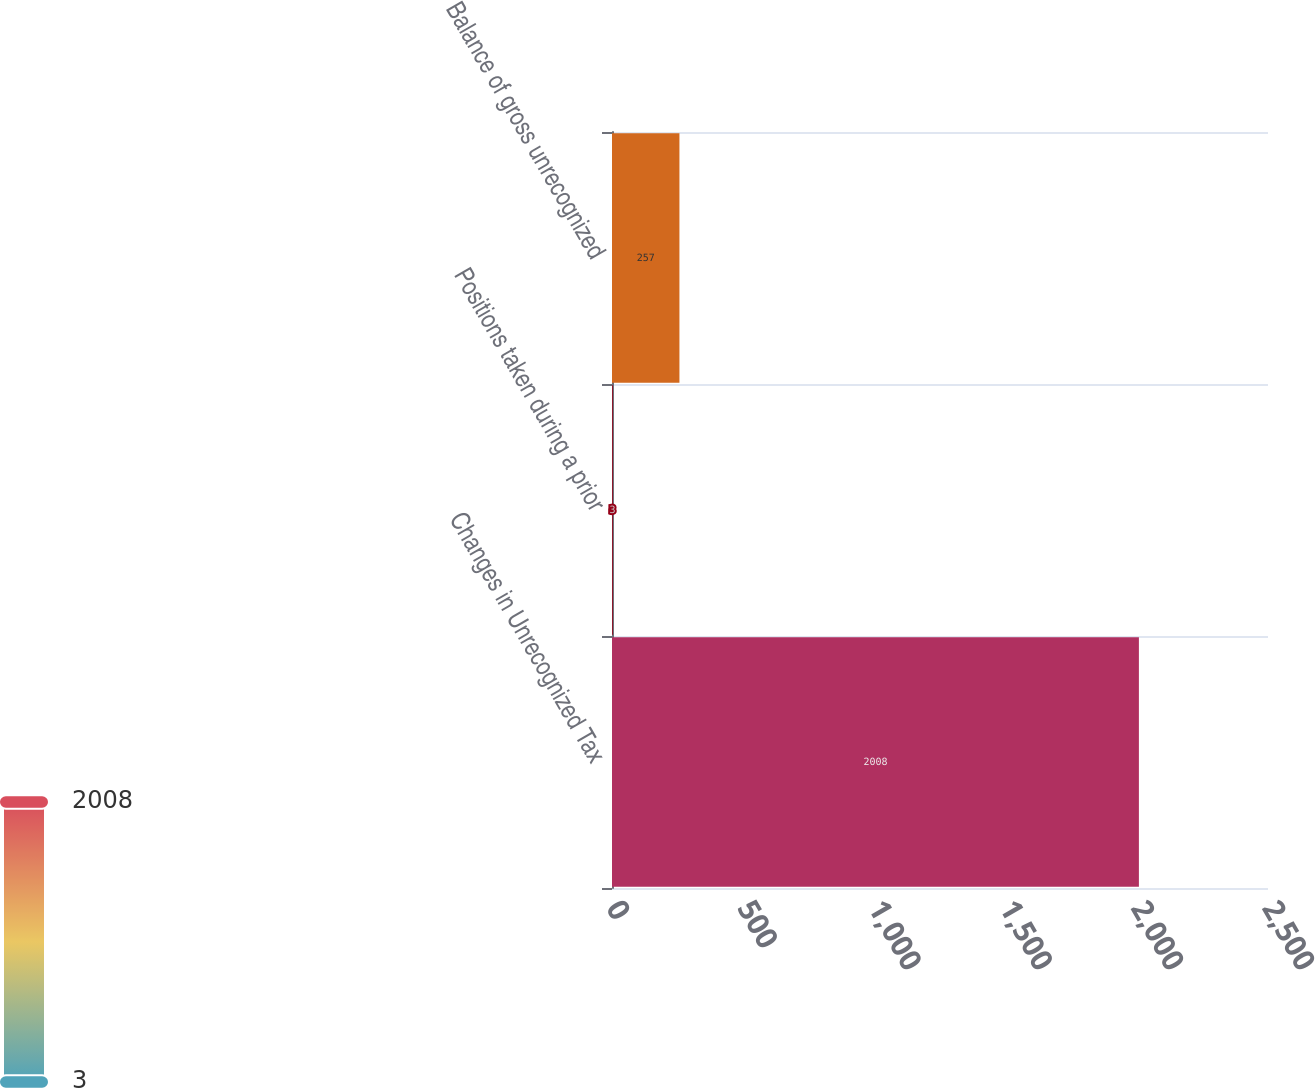Convert chart. <chart><loc_0><loc_0><loc_500><loc_500><bar_chart><fcel>Changes in Unrecognized Tax<fcel>Positions taken during a prior<fcel>Balance of gross unrecognized<nl><fcel>2008<fcel>3<fcel>257<nl></chart> 